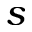Convert formula to latex. <formula><loc_0><loc_0><loc_500><loc_500>s</formula> 